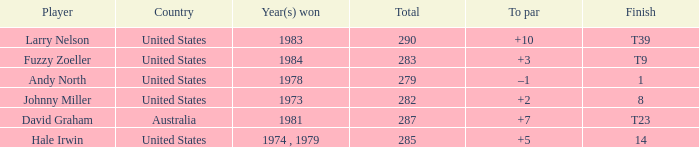Which player finished at +10? Larry Nelson. 